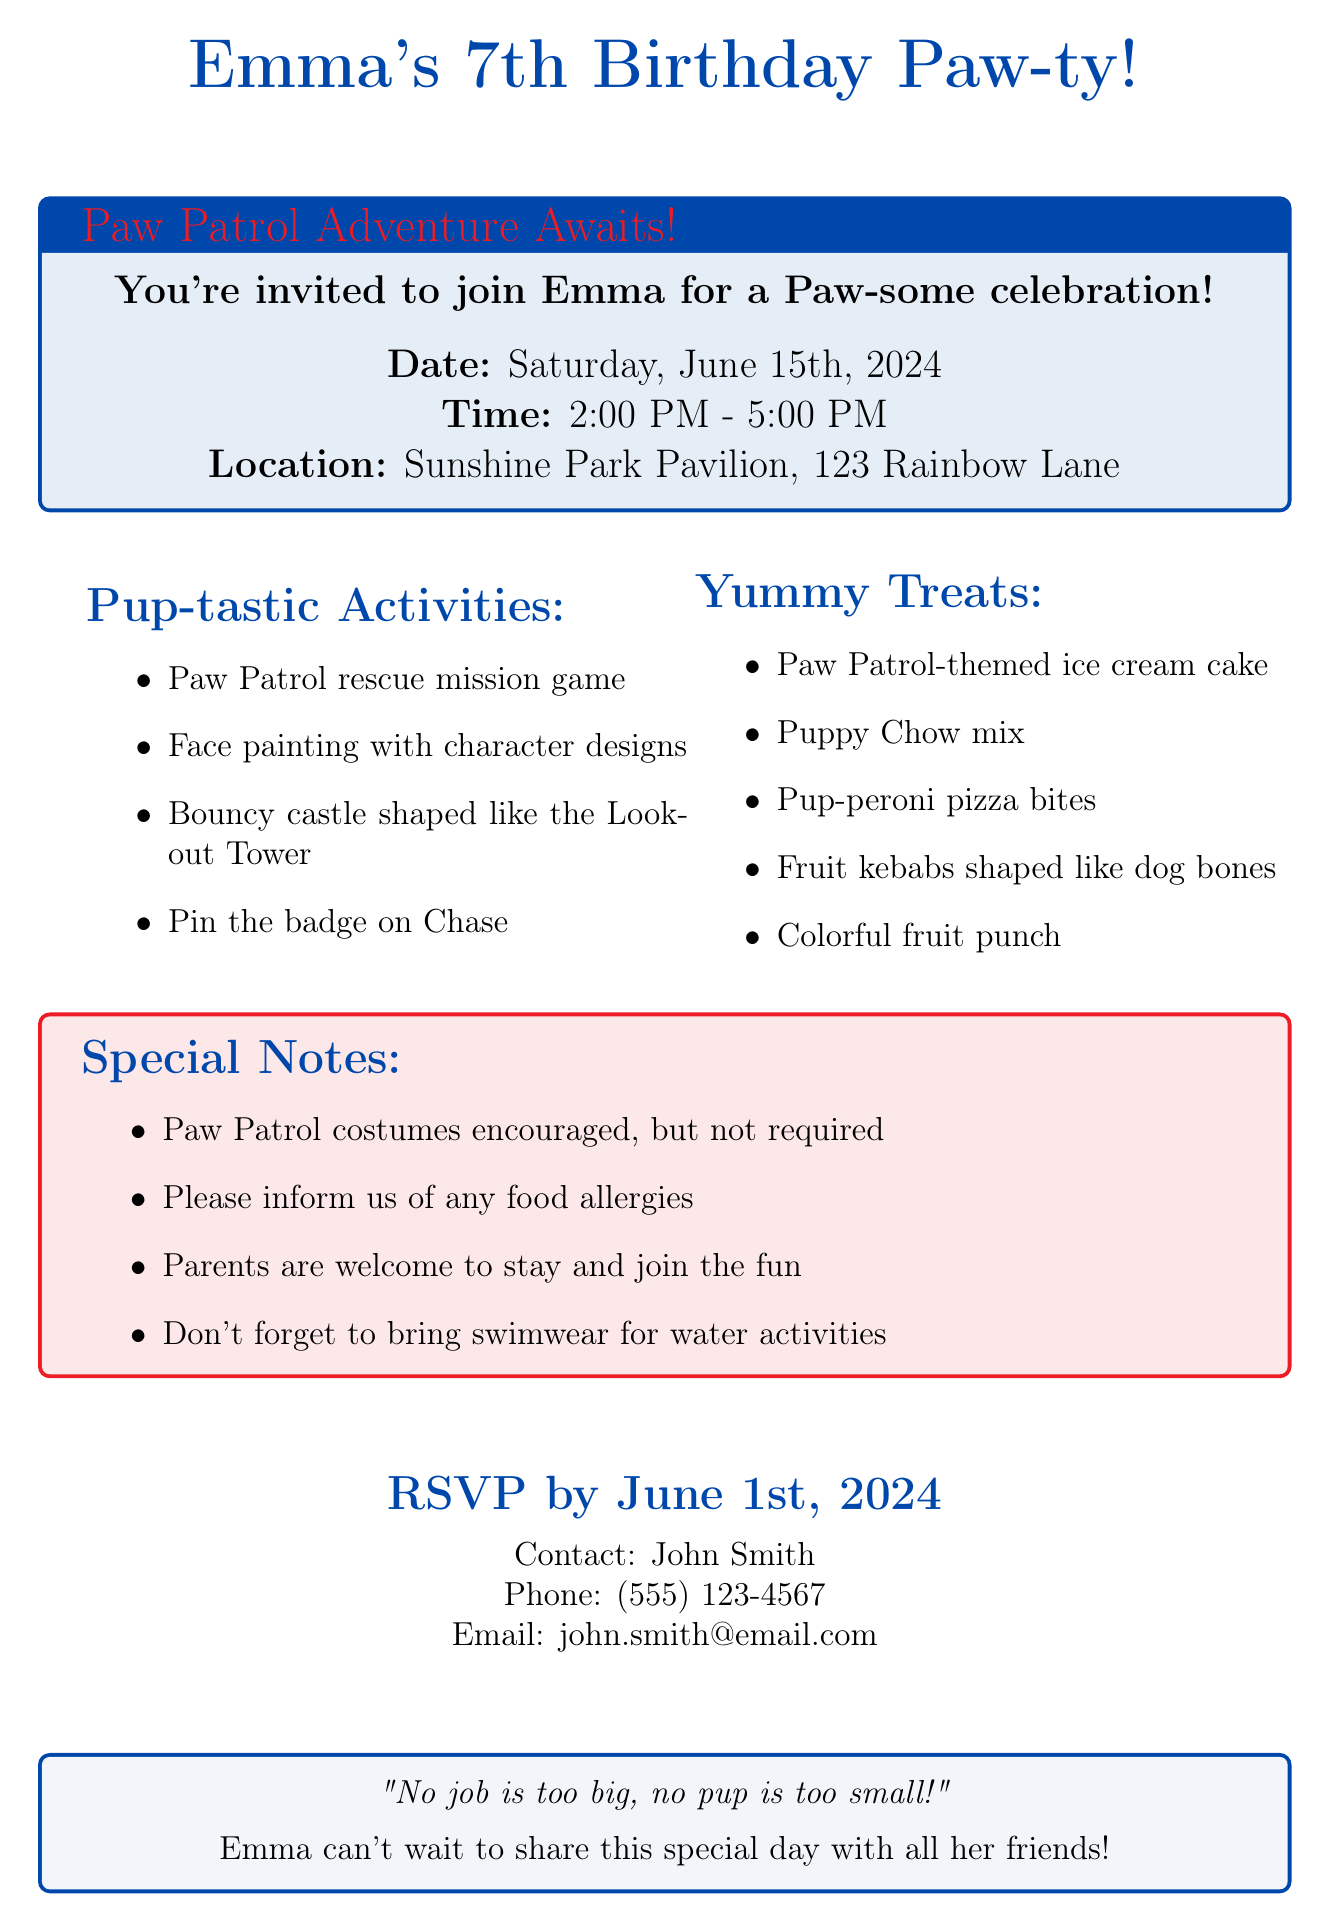What is Emma's age? Emma's age is specifically mentioned in the invitation details.
Answer: 7 What is the date of the birthday party? The date is explicitly stated in the invitation details section of the document.
Answer: Saturday, June 15th, 2024 What are the names of two favorite cartoon characters mentioned? The document lists a few characters, and two were requested.
Answer: Chase, Skye What activities will be included at the party? The invitation details a list of activities planned for the party.
Answer: Paw Patrol rescue mission game What type of cake will be served? The specific cake type is mentioned in the food section of the invitation.
Answer: Paw Patrol-themed ice cream cake What is the RSVP deadline? The document states the date by which guests should respond.
Answer: June 1st, 2024 What is the dress code for the party? The invitation includes a specific guideline regarding attire for the event.
Answer: Paw Patrol costumes encouraged, but not required Who should guests contact for RSVP? The document provides a name for RSVP inquiries.
Answer: John Smith How long will the party last? The time frame for the event is clearly defined in the invitation.
Answer: 2:00 PM - 5:00 PM 